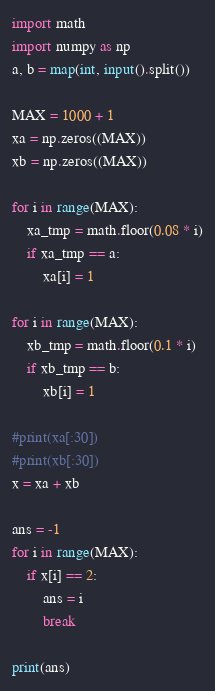<code> <loc_0><loc_0><loc_500><loc_500><_Python_>import math
import numpy as np
a, b = map(int, input().split())

MAX = 1000 + 1
xa = np.zeros((MAX))
xb = np.zeros((MAX))

for i in range(MAX):
    xa_tmp = math.floor(0.08 * i)
    if xa_tmp == a:
        xa[i] = 1

for i in range(MAX):
    xb_tmp = math.floor(0.1 * i)
    if xb_tmp == b:
        xb[i] = 1

#print(xa[:30])
#print(xb[:30])
x = xa + xb

ans = -1
for i in range(MAX):
    if x[i] == 2:
        ans = i
        break

print(ans)
</code> 